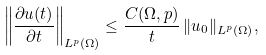Convert formula to latex. <formula><loc_0><loc_0><loc_500><loc_500>\left \| \frac { \partial u ( t ) } { \partial t } \right \| _ { L ^ { p } ( \Omega ) } \leq \frac { C ( \Omega , p ) } { t } \, \| u _ { 0 } \| _ { L ^ { p } ( \Omega ) } ,</formula> 